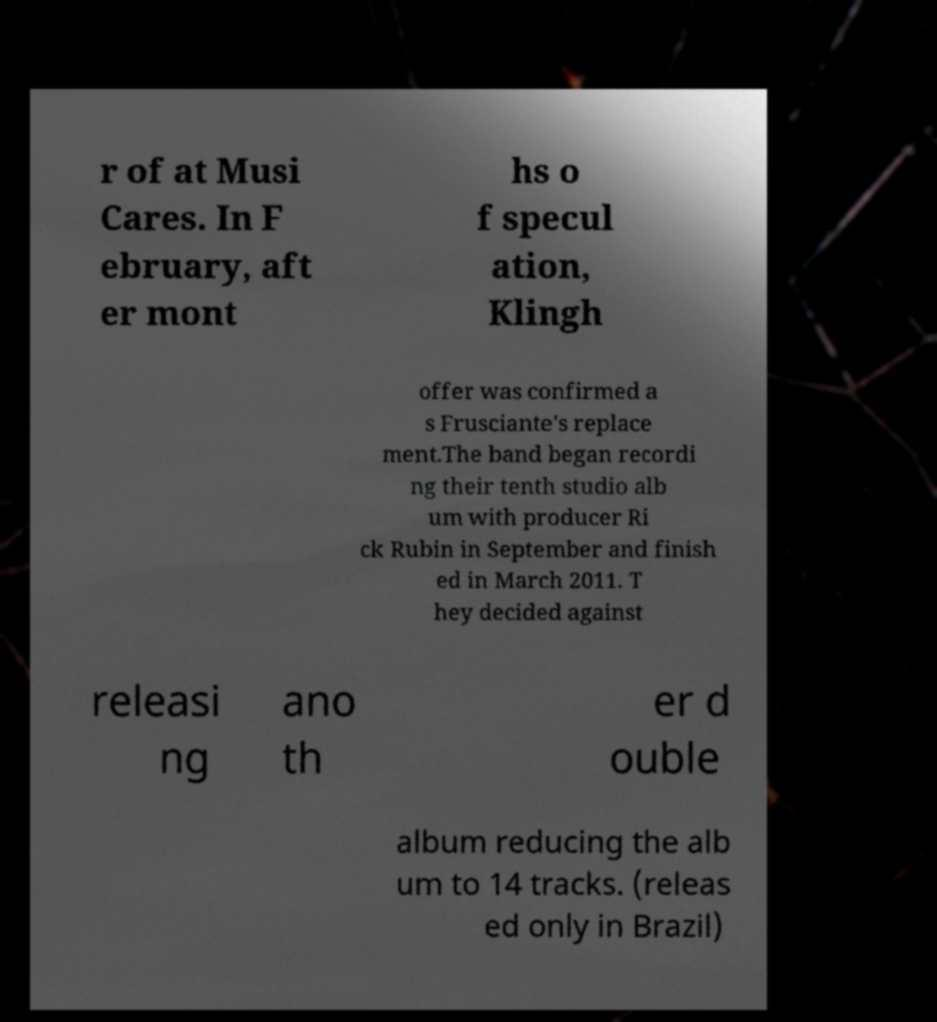Could you extract and type out the text from this image? r of at Musi Cares. In F ebruary, aft er mont hs o f specul ation, Klingh offer was confirmed a s Frusciante's replace ment.The band began recordi ng their tenth studio alb um with producer Ri ck Rubin in September and finish ed in March 2011. T hey decided against releasi ng ano th er d ouble album reducing the alb um to 14 tracks. (releas ed only in Brazil) 